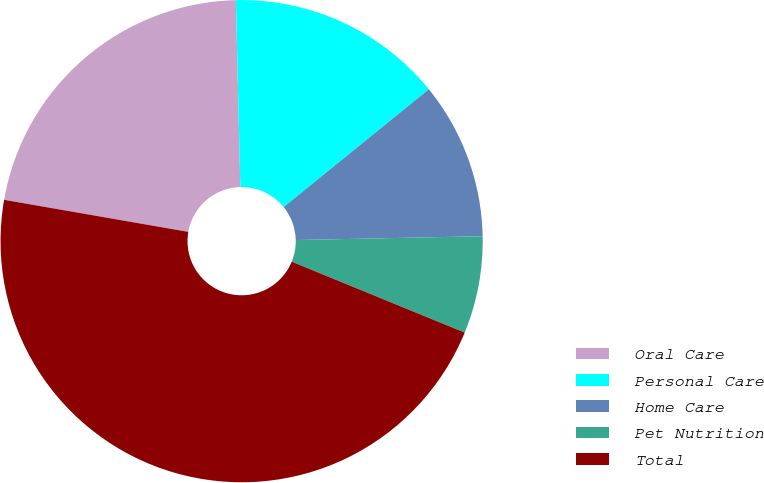Convert chart to OTSL. <chart><loc_0><loc_0><loc_500><loc_500><pie_chart><fcel>Oral Care<fcel>Personal Care<fcel>Home Care<fcel>Pet Nutrition<fcel>Total<nl><fcel>21.88%<fcel>14.53%<fcel>10.52%<fcel>6.52%<fcel>46.55%<nl></chart> 